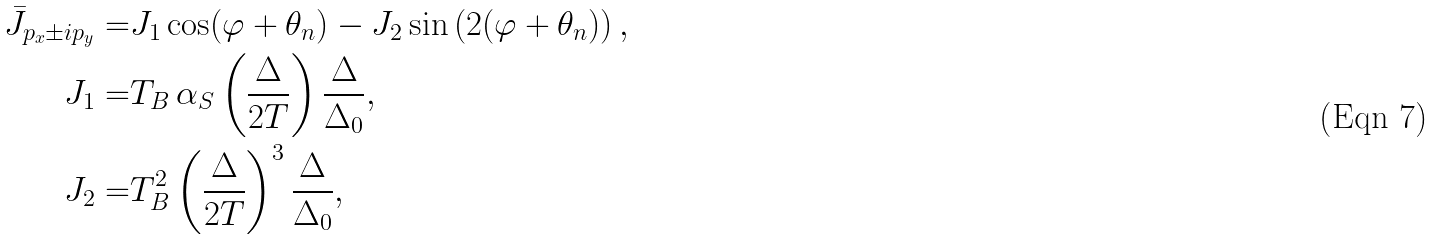Convert formula to latex. <formula><loc_0><loc_0><loc_500><loc_500>\bar { J } _ { p _ { x } \pm i p _ { y } } = & J _ { 1 } \cos ( \varphi + \theta _ { n } ) - J _ { 2 } \sin \left ( 2 ( \varphi + \theta _ { n } ) \right ) , \\ J _ { 1 } = & T _ { B } \, \alpha _ { S } \left ( \frac { \Delta } { 2 T } \right ) \frac { \Delta } { \Delta _ { 0 } } , \\ J _ { 2 } = & T _ { B } ^ { 2 } \left ( \frac { \Delta } { 2 T } \right ) ^ { 3 } \frac { \Delta } { \Delta _ { 0 } } ,</formula> 